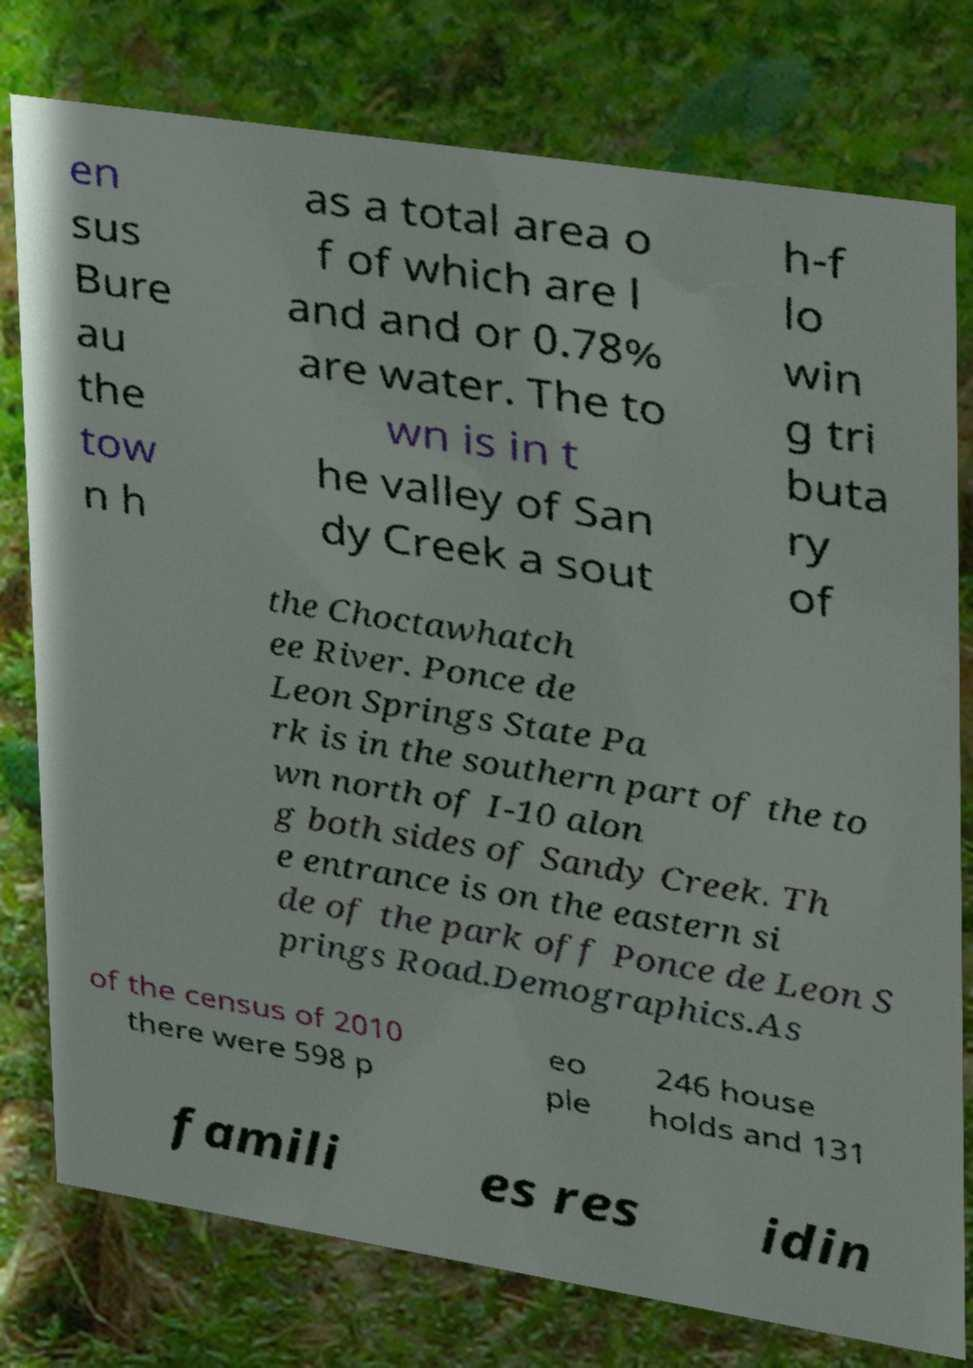What messages or text are displayed in this image? I need them in a readable, typed format. en sus Bure au the tow n h as a total area o f of which are l and and or 0.78% are water. The to wn is in t he valley of San dy Creek a sout h-f lo win g tri buta ry of the Choctawhatch ee River. Ponce de Leon Springs State Pa rk is in the southern part of the to wn north of I-10 alon g both sides of Sandy Creek. Th e entrance is on the eastern si de of the park off Ponce de Leon S prings Road.Demographics.As of the census of 2010 there were 598 p eo ple 246 house holds and 131 famili es res idin 